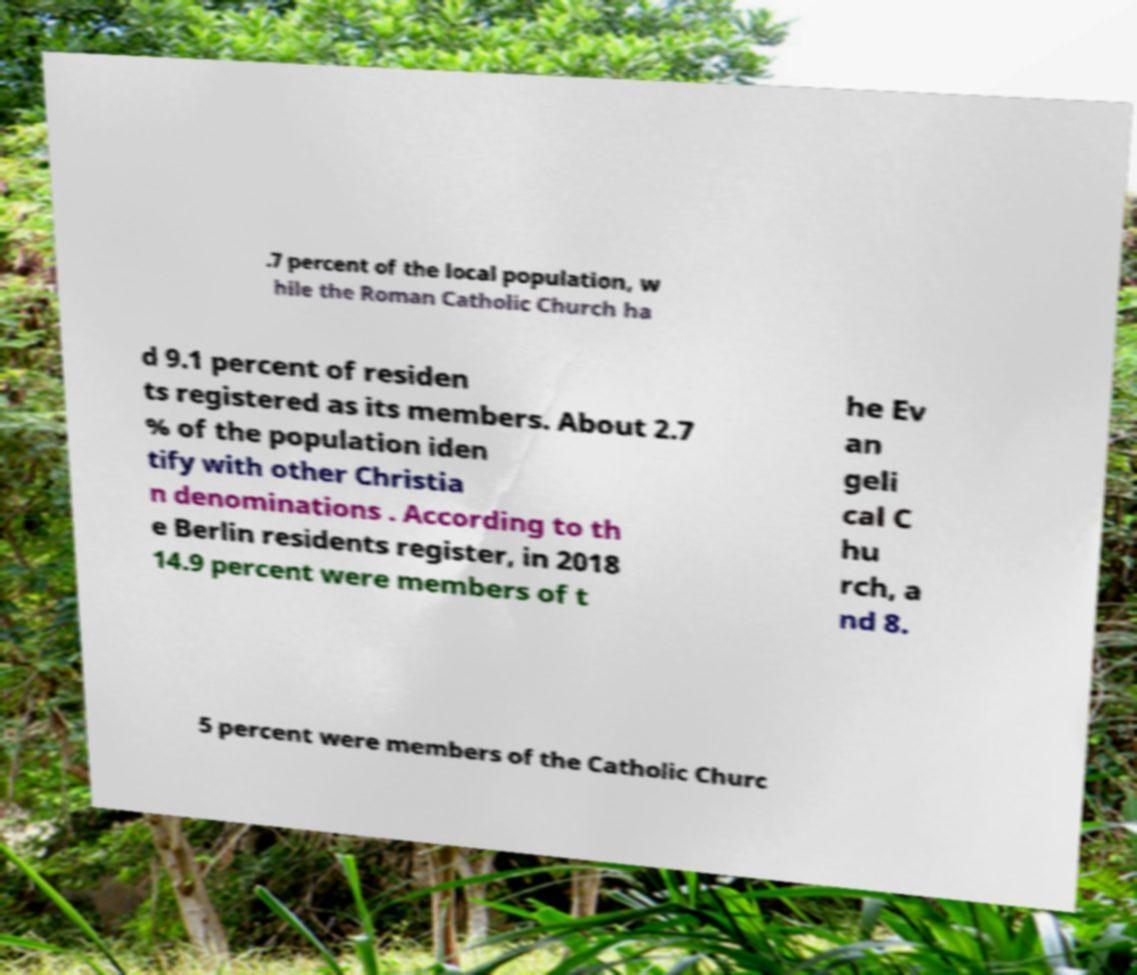For documentation purposes, I need the text within this image transcribed. Could you provide that? .7 percent of the local population, w hile the Roman Catholic Church ha d 9.1 percent of residen ts registered as its members. About 2.7 % of the population iden tify with other Christia n denominations . According to th e Berlin residents register, in 2018 14.9 percent were members of t he Ev an geli cal C hu rch, a nd 8. 5 percent were members of the Catholic Churc 